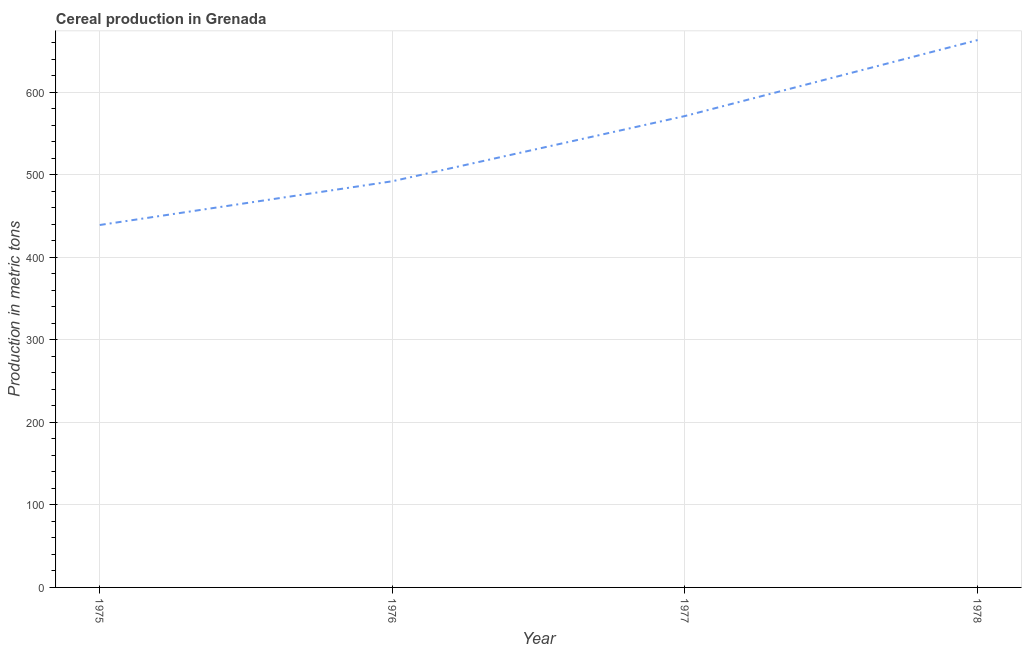What is the cereal production in 1975?
Keep it short and to the point. 439. Across all years, what is the maximum cereal production?
Offer a terse response. 663. Across all years, what is the minimum cereal production?
Offer a very short reply. 439. In which year was the cereal production maximum?
Give a very brief answer. 1978. In which year was the cereal production minimum?
Your response must be concise. 1975. What is the sum of the cereal production?
Ensure brevity in your answer.  2165. What is the difference between the cereal production in 1975 and 1977?
Ensure brevity in your answer.  -132. What is the average cereal production per year?
Provide a succinct answer. 541.25. What is the median cereal production?
Your answer should be compact. 531.5. In how many years, is the cereal production greater than 100 metric tons?
Give a very brief answer. 4. What is the ratio of the cereal production in 1976 to that in 1978?
Offer a terse response. 0.74. Is the difference between the cereal production in 1975 and 1976 greater than the difference between any two years?
Give a very brief answer. No. What is the difference between the highest and the second highest cereal production?
Your answer should be compact. 92. Is the sum of the cereal production in 1975 and 1976 greater than the maximum cereal production across all years?
Offer a very short reply. Yes. What is the difference between the highest and the lowest cereal production?
Give a very brief answer. 224. In how many years, is the cereal production greater than the average cereal production taken over all years?
Ensure brevity in your answer.  2. How many lines are there?
Make the answer very short. 1. Are the values on the major ticks of Y-axis written in scientific E-notation?
Provide a succinct answer. No. Does the graph contain grids?
Keep it short and to the point. Yes. What is the title of the graph?
Your response must be concise. Cereal production in Grenada. What is the label or title of the X-axis?
Your response must be concise. Year. What is the label or title of the Y-axis?
Your response must be concise. Production in metric tons. What is the Production in metric tons of 1975?
Make the answer very short. 439. What is the Production in metric tons in 1976?
Keep it short and to the point. 492. What is the Production in metric tons in 1977?
Offer a very short reply. 571. What is the Production in metric tons in 1978?
Keep it short and to the point. 663. What is the difference between the Production in metric tons in 1975 and 1976?
Your answer should be compact. -53. What is the difference between the Production in metric tons in 1975 and 1977?
Your answer should be compact. -132. What is the difference between the Production in metric tons in 1975 and 1978?
Your answer should be compact. -224. What is the difference between the Production in metric tons in 1976 and 1977?
Give a very brief answer. -79. What is the difference between the Production in metric tons in 1976 and 1978?
Keep it short and to the point. -171. What is the difference between the Production in metric tons in 1977 and 1978?
Offer a terse response. -92. What is the ratio of the Production in metric tons in 1975 to that in 1976?
Provide a short and direct response. 0.89. What is the ratio of the Production in metric tons in 1975 to that in 1977?
Keep it short and to the point. 0.77. What is the ratio of the Production in metric tons in 1975 to that in 1978?
Your answer should be compact. 0.66. What is the ratio of the Production in metric tons in 1976 to that in 1977?
Provide a succinct answer. 0.86. What is the ratio of the Production in metric tons in 1976 to that in 1978?
Provide a short and direct response. 0.74. What is the ratio of the Production in metric tons in 1977 to that in 1978?
Provide a short and direct response. 0.86. 